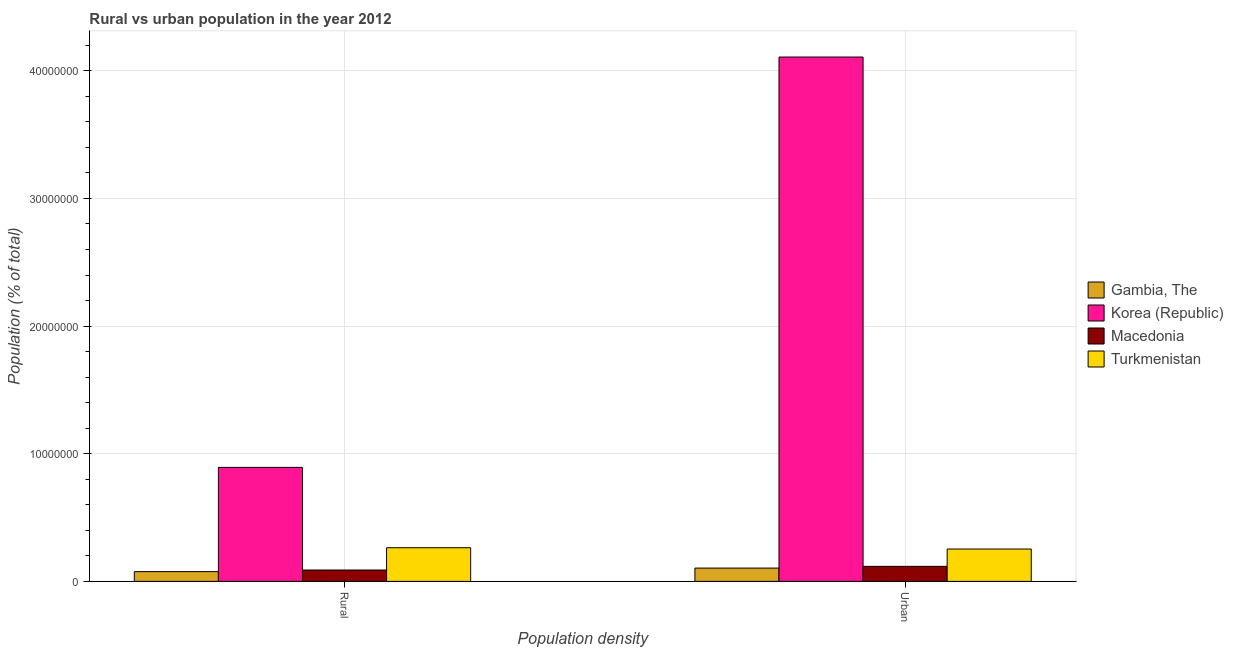How many different coloured bars are there?
Provide a short and direct response. 4. How many groups of bars are there?
Ensure brevity in your answer.  2. How many bars are there on the 2nd tick from the left?
Ensure brevity in your answer.  4. How many bars are there on the 2nd tick from the right?
Offer a very short reply. 4. What is the label of the 1st group of bars from the left?
Your answer should be very brief. Rural. What is the urban population density in Gambia, The?
Your answer should be very brief. 1.04e+06. Across all countries, what is the maximum urban population density?
Give a very brief answer. 4.11e+07. Across all countries, what is the minimum rural population density?
Provide a short and direct response. 7.64e+05. In which country was the urban population density maximum?
Provide a succinct answer. Korea (Republic). In which country was the urban population density minimum?
Keep it short and to the point. Gambia, The. What is the total rural population density in the graph?
Your answer should be very brief. 1.32e+07. What is the difference between the urban population density in Macedonia and that in Korea (Republic)?
Offer a terse response. -3.99e+07. What is the difference between the rural population density in Korea (Republic) and the urban population density in Turkmenistan?
Provide a succinct answer. 6.39e+06. What is the average rural population density per country?
Offer a very short reply. 3.31e+06. What is the difference between the urban population density and rural population density in Macedonia?
Your answer should be very brief. 2.88e+05. What is the ratio of the urban population density in Korea (Republic) to that in Macedonia?
Provide a succinct answer. 34.85. Is the rural population density in Korea (Republic) less than that in Macedonia?
Your answer should be very brief. No. What does the 4th bar from the right in Rural represents?
Give a very brief answer. Gambia, The. Are all the bars in the graph horizontal?
Your answer should be compact. No. What is the difference between two consecutive major ticks on the Y-axis?
Your response must be concise. 1.00e+07. Are the values on the major ticks of Y-axis written in scientific E-notation?
Give a very brief answer. No. Does the graph contain any zero values?
Make the answer very short. No. Does the graph contain grids?
Your answer should be compact. Yes. How many legend labels are there?
Keep it short and to the point. 4. How are the legend labels stacked?
Offer a very short reply. Vertical. What is the title of the graph?
Provide a succinct answer. Rural vs urban population in the year 2012. Does "Finland" appear as one of the legend labels in the graph?
Give a very brief answer. No. What is the label or title of the X-axis?
Offer a terse response. Population density. What is the label or title of the Y-axis?
Provide a succinct answer. Population (% of total). What is the Population (% of total) in Gambia, The in Rural?
Your response must be concise. 7.64e+05. What is the Population (% of total) in Korea (Republic) in Rural?
Provide a short and direct response. 8.93e+06. What is the Population (% of total) of Macedonia in Rural?
Your answer should be compact. 8.91e+05. What is the Population (% of total) in Turkmenistan in Rural?
Your answer should be very brief. 2.64e+06. What is the Population (% of total) of Gambia, The in Urban?
Offer a very short reply. 1.04e+06. What is the Population (% of total) in Korea (Republic) in Urban?
Ensure brevity in your answer.  4.11e+07. What is the Population (% of total) in Macedonia in Urban?
Your response must be concise. 1.18e+06. What is the Population (% of total) in Turkmenistan in Urban?
Offer a very short reply. 2.54e+06. Across all Population density, what is the maximum Population (% of total) in Gambia, The?
Make the answer very short. 1.04e+06. Across all Population density, what is the maximum Population (% of total) in Korea (Republic)?
Your answer should be compact. 4.11e+07. Across all Population density, what is the maximum Population (% of total) of Macedonia?
Ensure brevity in your answer.  1.18e+06. Across all Population density, what is the maximum Population (% of total) in Turkmenistan?
Offer a very short reply. 2.64e+06. Across all Population density, what is the minimum Population (% of total) in Gambia, The?
Offer a very short reply. 7.64e+05. Across all Population density, what is the minimum Population (% of total) of Korea (Republic)?
Offer a very short reply. 8.93e+06. Across all Population density, what is the minimum Population (% of total) in Macedonia?
Give a very brief answer. 8.91e+05. Across all Population density, what is the minimum Population (% of total) of Turkmenistan?
Provide a succinct answer. 2.54e+06. What is the total Population (% of total) in Gambia, The in the graph?
Ensure brevity in your answer.  1.81e+06. What is the total Population (% of total) of Korea (Republic) in the graph?
Your answer should be very brief. 5.00e+07. What is the total Population (% of total) in Macedonia in the graph?
Provide a succinct answer. 2.07e+06. What is the total Population (% of total) in Turkmenistan in the graph?
Your answer should be compact. 5.17e+06. What is the difference between the Population (% of total) in Gambia, The in Rural and that in Urban?
Provide a succinct answer. -2.79e+05. What is the difference between the Population (% of total) of Korea (Republic) in Rural and that in Urban?
Offer a terse response. -3.21e+07. What is the difference between the Population (% of total) in Macedonia in Rural and that in Urban?
Your answer should be compact. -2.88e+05. What is the difference between the Population (% of total) of Turkmenistan in Rural and that in Urban?
Your response must be concise. 1.01e+05. What is the difference between the Population (% of total) in Gambia, The in Rural and the Population (% of total) in Korea (Republic) in Urban?
Offer a terse response. -4.03e+07. What is the difference between the Population (% of total) in Gambia, The in Rural and the Population (% of total) in Macedonia in Urban?
Make the answer very short. -4.14e+05. What is the difference between the Population (% of total) in Gambia, The in Rural and the Population (% of total) in Turkmenistan in Urban?
Keep it short and to the point. -1.77e+06. What is the difference between the Population (% of total) of Korea (Republic) in Rural and the Population (% of total) of Macedonia in Urban?
Make the answer very short. 7.75e+06. What is the difference between the Population (% of total) of Korea (Republic) in Rural and the Population (% of total) of Turkmenistan in Urban?
Provide a short and direct response. 6.39e+06. What is the difference between the Population (% of total) of Macedonia in Rural and the Population (% of total) of Turkmenistan in Urban?
Give a very brief answer. -1.65e+06. What is the average Population (% of total) of Gambia, The per Population density?
Make the answer very short. 9.04e+05. What is the average Population (% of total) of Korea (Republic) per Population density?
Your answer should be very brief. 2.50e+07. What is the average Population (% of total) of Macedonia per Population density?
Your answer should be compact. 1.03e+06. What is the average Population (% of total) of Turkmenistan per Population density?
Keep it short and to the point. 2.59e+06. What is the difference between the Population (% of total) of Gambia, The and Population (% of total) of Korea (Republic) in Rural?
Offer a terse response. -8.17e+06. What is the difference between the Population (% of total) of Gambia, The and Population (% of total) of Macedonia in Rural?
Provide a succinct answer. -1.26e+05. What is the difference between the Population (% of total) in Gambia, The and Population (% of total) in Turkmenistan in Rural?
Offer a very short reply. -1.87e+06. What is the difference between the Population (% of total) in Korea (Republic) and Population (% of total) in Macedonia in Rural?
Your answer should be very brief. 8.04e+06. What is the difference between the Population (% of total) of Korea (Republic) and Population (% of total) of Turkmenistan in Rural?
Offer a very short reply. 6.29e+06. What is the difference between the Population (% of total) in Macedonia and Population (% of total) in Turkmenistan in Rural?
Your answer should be compact. -1.75e+06. What is the difference between the Population (% of total) of Gambia, The and Population (% of total) of Korea (Republic) in Urban?
Your answer should be compact. -4.00e+07. What is the difference between the Population (% of total) in Gambia, The and Population (% of total) in Macedonia in Urban?
Make the answer very short. -1.36e+05. What is the difference between the Population (% of total) in Gambia, The and Population (% of total) in Turkmenistan in Urban?
Offer a very short reply. -1.49e+06. What is the difference between the Population (% of total) of Korea (Republic) and Population (% of total) of Macedonia in Urban?
Ensure brevity in your answer.  3.99e+07. What is the difference between the Population (% of total) of Korea (Republic) and Population (% of total) of Turkmenistan in Urban?
Your answer should be very brief. 3.85e+07. What is the difference between the Population (% of total) in Macedonia and Population (% of total) in Turkmenistan in Urban?
Offer a very short reply. -1.36e+06. What is the ratio of the Population (% of total) in Gambia, The in Rural to that in Urban?
Provide a short and direct response. 0.73. What is the ratio of the Population (% of total) of Korea (Republic) in Rural to that in Urban?
Make the answer very short. 0.22. What is the ratio of the Population (% of total) of Macedonia in Rural to that in Urban?
Keep it short and to the point. 0.76. What is the ratio of the Population (% of total) of Turkmenistan in Rural to that in Urban?
Make the answer very short. 1.04. What is the difference between the highest and the second highest Population (% of total) of Gambia, The?
Give a very brief answer. 2.79e+05. What is the difference between the highest and the second highest Population (% of total) of Korea (Republic)?
Give a very brief answer. 3.21e+07. What is the difference between the highest and the second highest Population (% of total) of Macedonia?
Ensure brevity in your answer.  2.88e+05. What is the difference between the highest and the second highest Population (% of total) in Turkmenistan?
Your response must be concise. 1.01e+05. What is the difference between the highest and the lowest Population (% of total) in Gambia, The?
Your answer should be compact. 2.79e+05. What is the difference between the highest and the lowest Population (% of total) of Korea (Republic)?
Ensure brevity in your answer.  3.21e+07. What is the difference between the highest and the lowest Population (% of total) of Macedonia?
Ensure brevity in your answer.  2.88e+05. What is the difference between the highest and the lowest Population (% of total) in Turkmenistan?
Provide a succinct answer. 1.01e+05. 